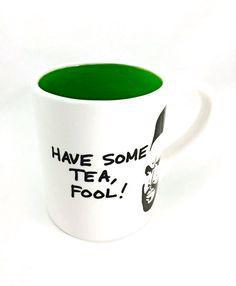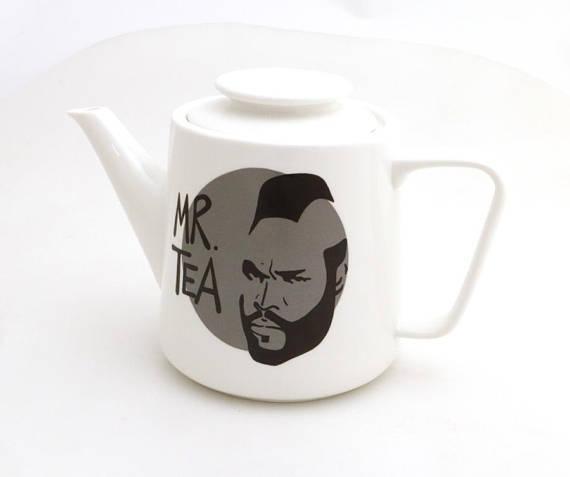The first image is the image on the left, the second image is the image on the right. For the images displayed, is the sentence "The combined images contain exactly two mugs, with handles facing opposite directions and a face on each mug." factually correct? Answer yes or no. No. The first image is the image on the left, the second image is the image on the right. Analyze the images presented: Is the assertion "One cup is in each image, each decorated with the same person's head, but the cup handles are in opposite directions." valid? Answer yes or no. No. 